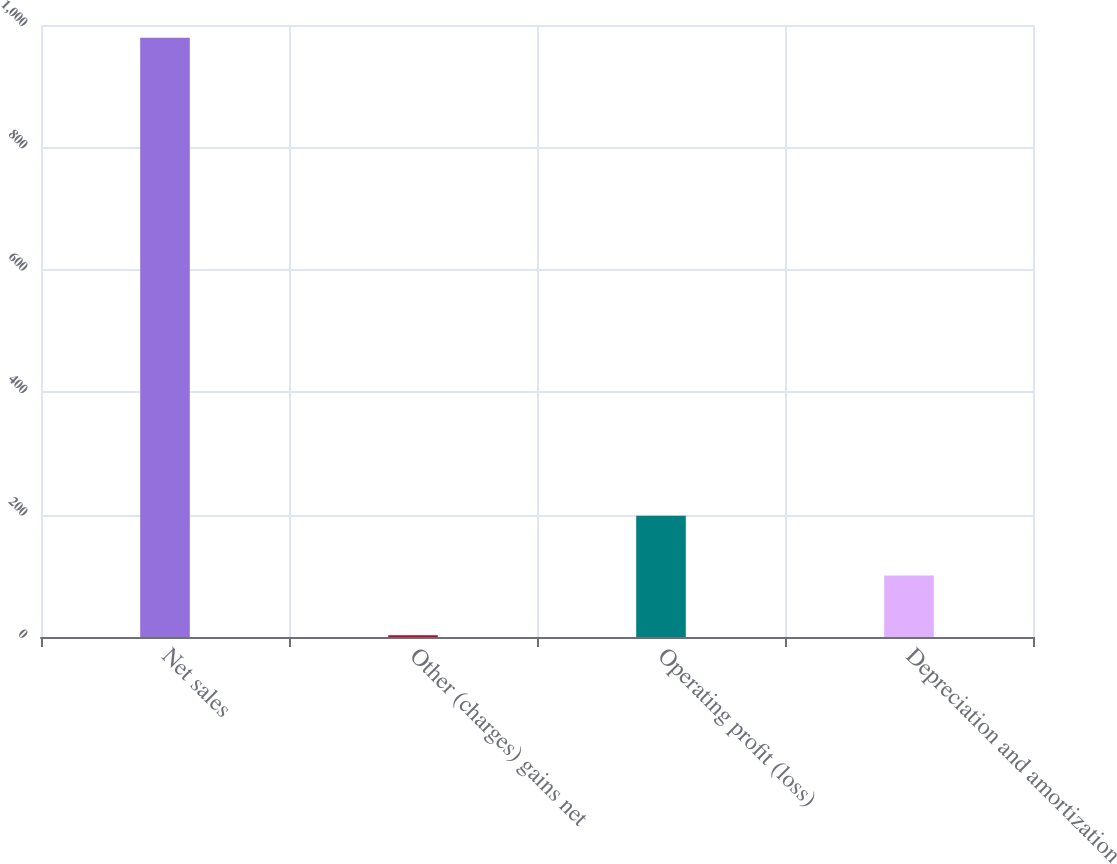Convert chart. <chart><loc_0><loc_0><loc_500><loc_500><bar_chart><fcel>Net sales<fcel>Other (charges) gains net<fcel>Operating profit (loss)<fcel>Depreciation and amortization<nl><fcel>979<fcel>3<fcel>198.2<fcel>100.6<nl></chart> 